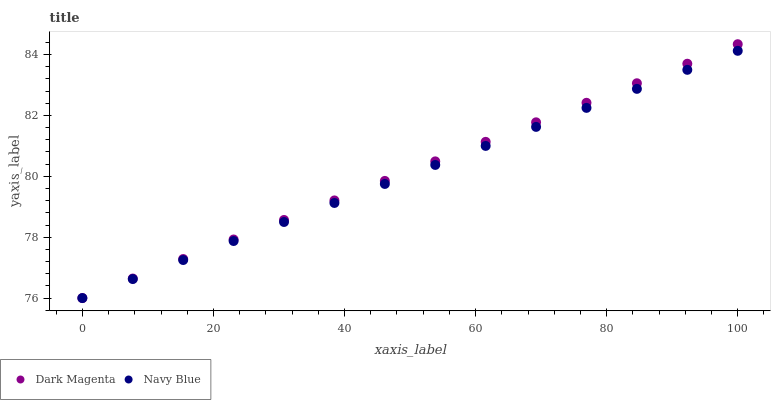Does Navy Blue have the minimum area under the curve?
Answer yes or no. Yes. Does Dark Magenta have the maximum area under the curve?
Answer yes or no. Yes. Does Dark Magenta have the minimum area under the curve?
Answer yes or no. No. Is Dark Magenta the smoothest?
Answer yes or no. Yes. Is Navy Blue the roughest?
Answer yes or no. Yes. Is Dark Magenta the roughest?
Answer yes or no. No. Does Navy Blue have the lowest value?
Answer yes or no. Yes. Does Dark Magenta have the highest value?
Answer yes or no. Yes. Does Navy Blue intersect Dark Magenta?
Answer yes or no. Yes. Is Navy Blue less than Dark Magenta?
Answer yes or no. No. Is Navy Blue greater than Dark Magenta?
Answer yes or no. No. 